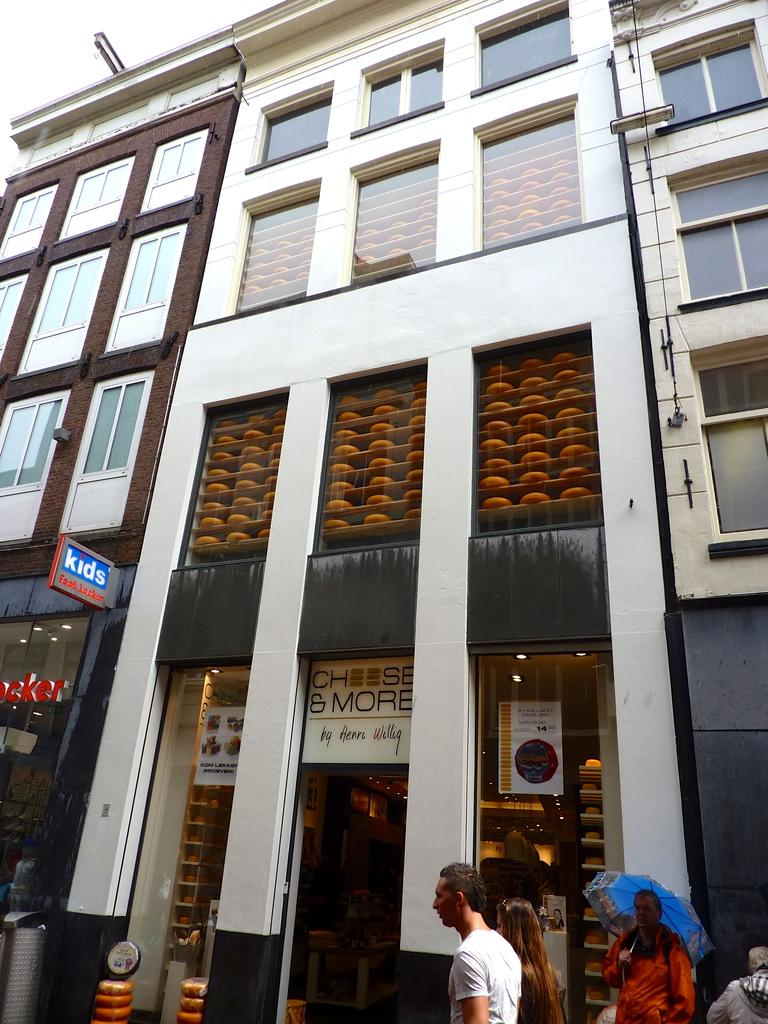What type of structure is present in the image? There is a building in the image. What object can be seen near the building? There is a dustbin in the image. Are there any people in the image? Yes, there are people in the image. Can you describe the man in the image? The man is holding an umbrella. What is visible at the top of the image? The sky is visible at the top of the image. What type of honey is being served at the meeting in the image? There is no meeting or honey present in the image. What is the man wearing on his wrist in the image? The man is not wearing a watch in the image; he is holding an umbrella. 